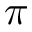Convert formula to latex. <formula><loc_0><loc_0><loc_500><loc_500>\pi</formula> 